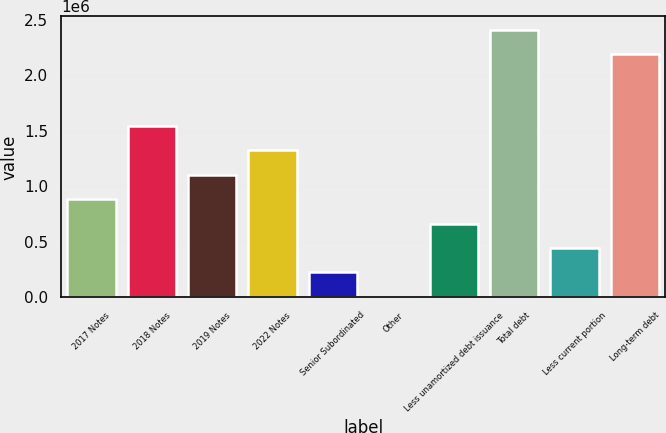<chart> <loc_0><loc_0><loc_500><loc_500><bar_chart><fcel>2017 Notes<fcel>2018 Notes<fcel>2019 Notes<fcel>2022 Notes<fcel>Senior Subordinated<fcel>Other<fcel>Less unamortized debt issuance<fcel>Total debt<fcel>Less current portion<fcel>Long-term debt<nl><fcel>884222<fcel>1.5428e+06<fcel>1.10375e+06<fcel>1.32327e+06<fcel>225645<fcel>6120<fcel>664696<fcel>2.40981e+06<fcel>445171<fcel>2.19028e+06<nl></chart> 